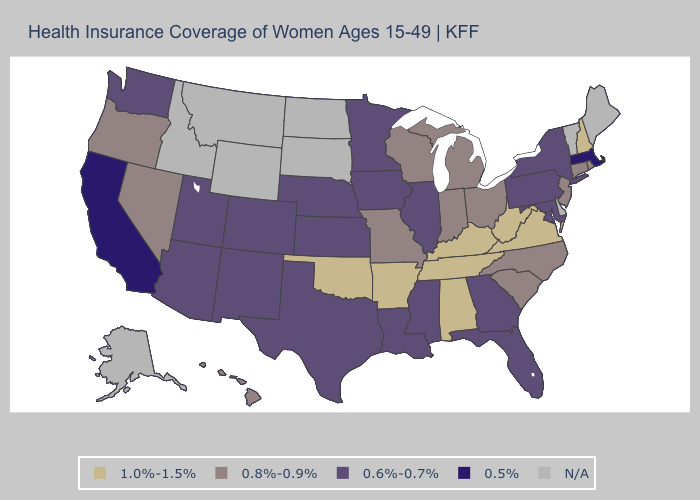Name the states that have a value in the range 0.8%-0.9%?
Quick response, please. Connecticut, Hawaii, Indiana, Michigan, Missouri, Nevada, New Jersey, North Carolina, Ohio, Oregon, Rhode Island, South Carolina, Wisconsin. Which states have the highest value in the USA?
Quick response, please. Alabama, Arkansas, Kentucky, New Hampshire, Oklahoma, Tennessee, Virginia, West Virginia. How many symbols are there in the legend?
Quick response, please. 5. Which states have the lowest value in the USA?
Answer briefly. California, Massachusetts. Which states have the lowest value in the MidWest?
Be succinct. Illinois, Iowa, Kansas, Minnesota, Nebraska. Does Massachusetts have the lowest value in the USA?
Write a very short answer. Yes. Which states have the lowest value in the USA?
Be succinct. California, Massachusetts. What is the highest value in the South ?
Answer briefly. 1.0%-1.5%. What is the value of Louisiana?
Be succinct. 0.6%-0.7%. What is the value of Arizona?
Give a very brief answer. 0.6%-0.7%. What is the value of Maryland?
Short answer required. 0.6%-0.7%. What is the value of North Dakota?
Keep it brief. N/A. Among the states that border New York , does New Jersey have the highest value?
Write a very short answer. Yes. What is the highest value in the MidWest ?
Short answer required. 0.8%-0.9%. 